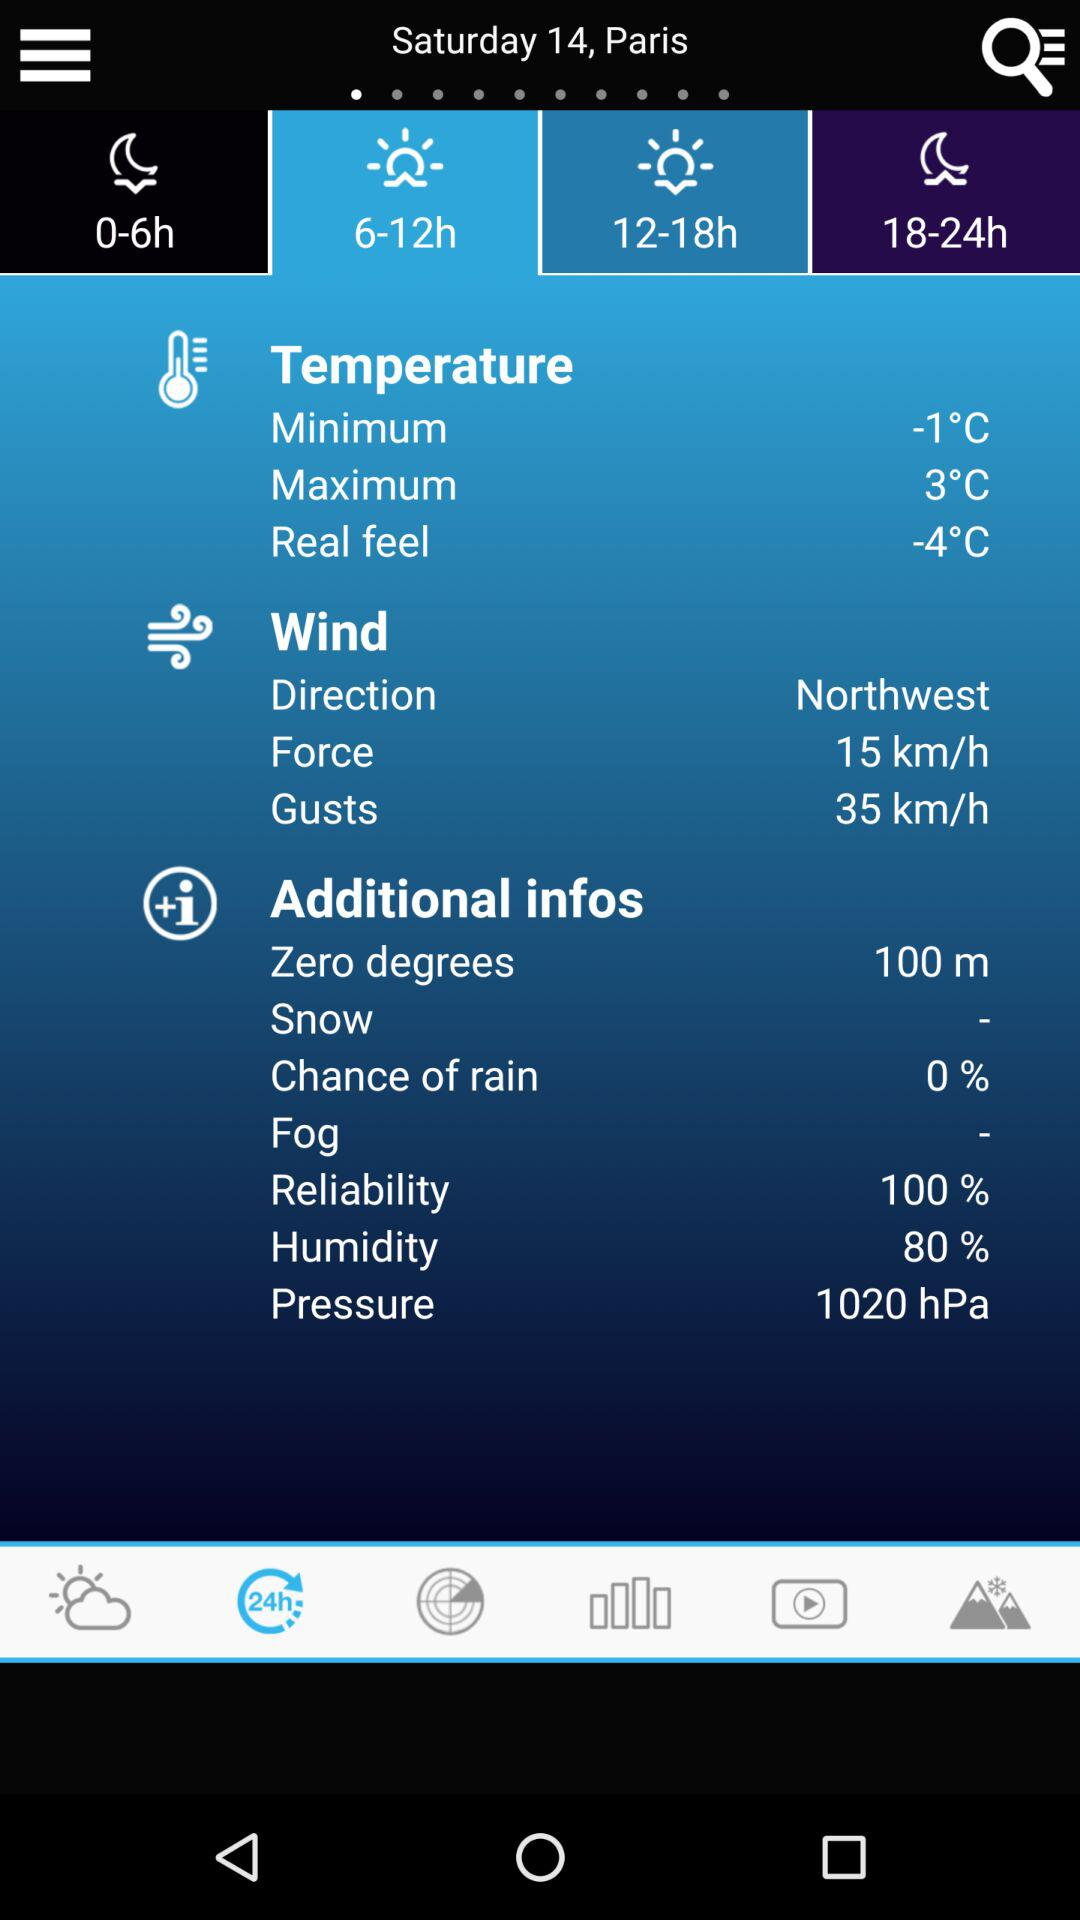What are the chances of rain? The chances of rain are 0%. 